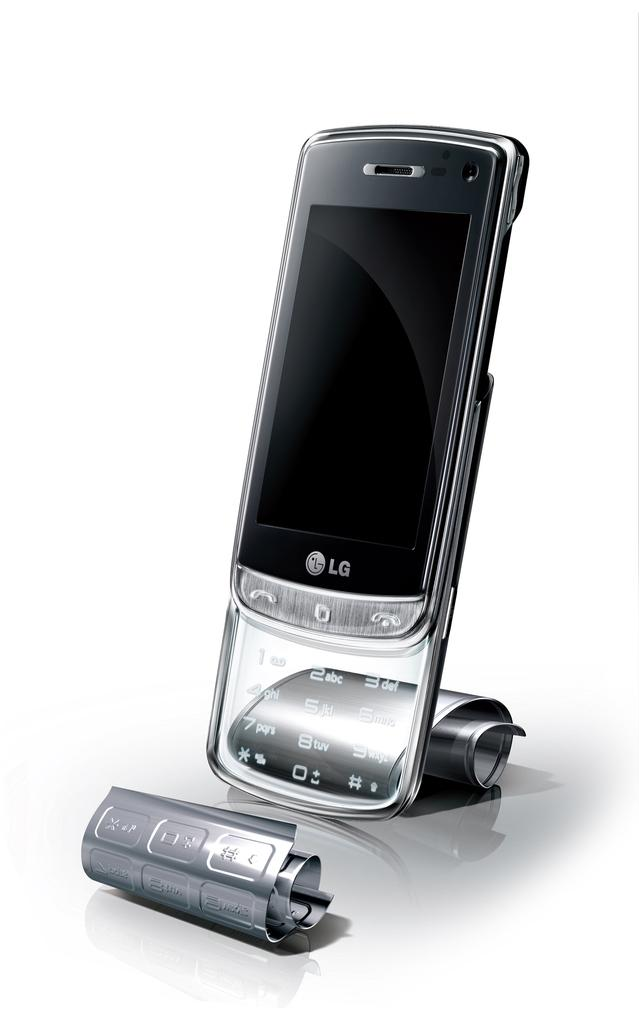<image>
Give a short and clear explanation of the subsequent image. a phone that has the word LG on it 